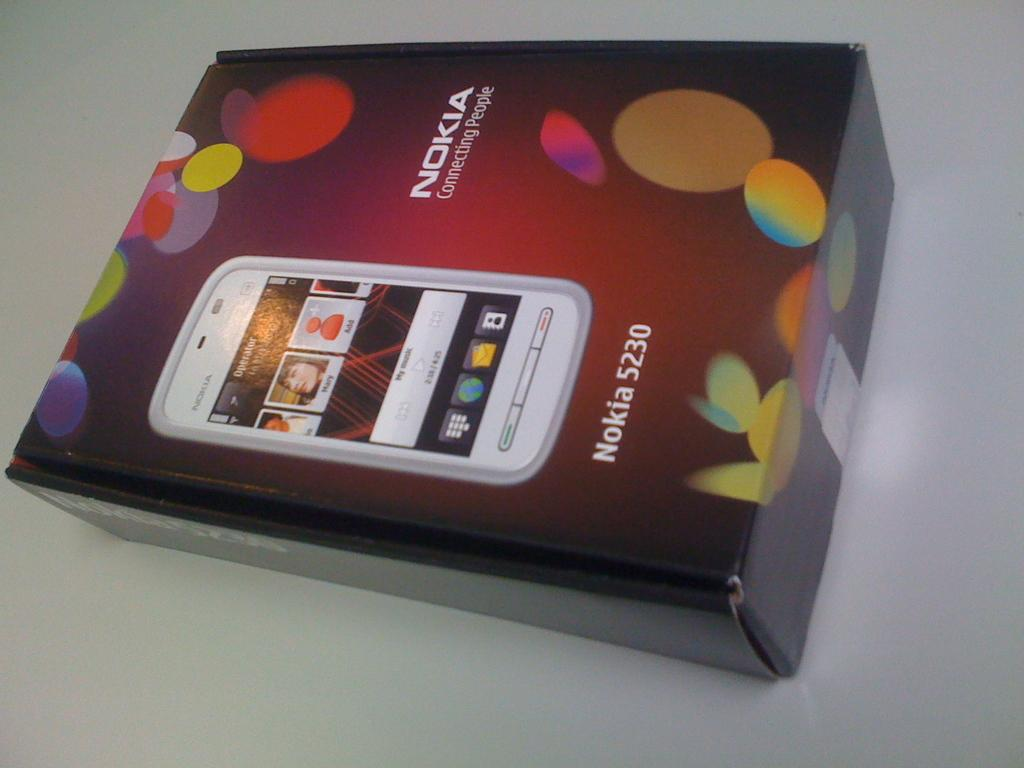<image>
Create a compact narrative representing the image presented. A Nokia 5230 phone box has a picture of the phone on the front. 